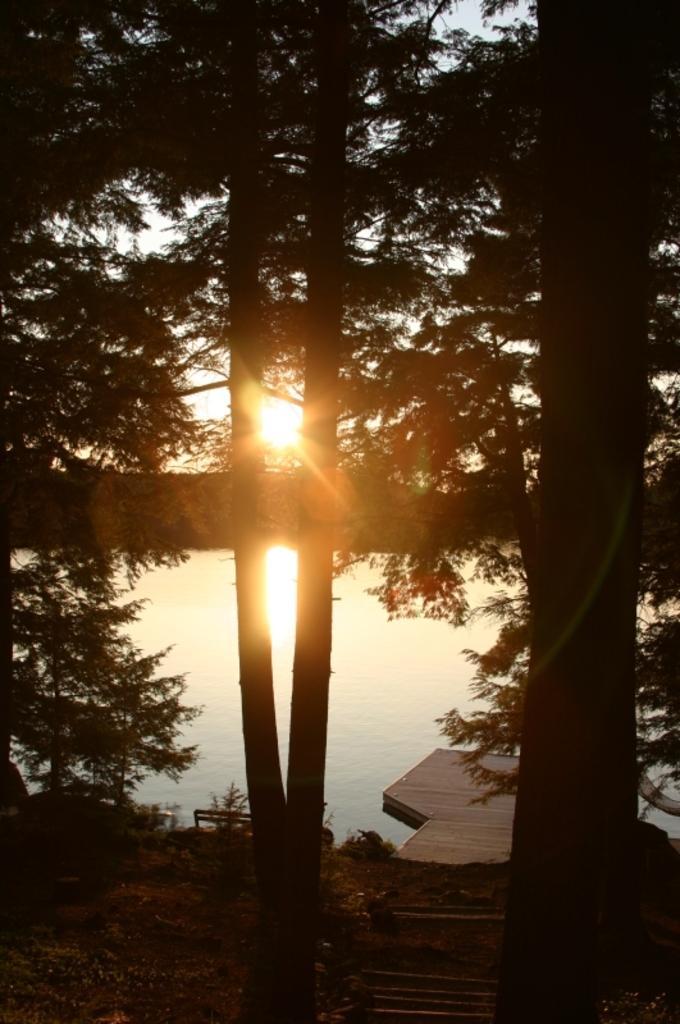In one or two sentences, can you explain what this image depicts? At the bottom there is a wooden plank on the water and I can see the ground. Here I can see the trees. In the background, I can see the sky along with the sunlight. 